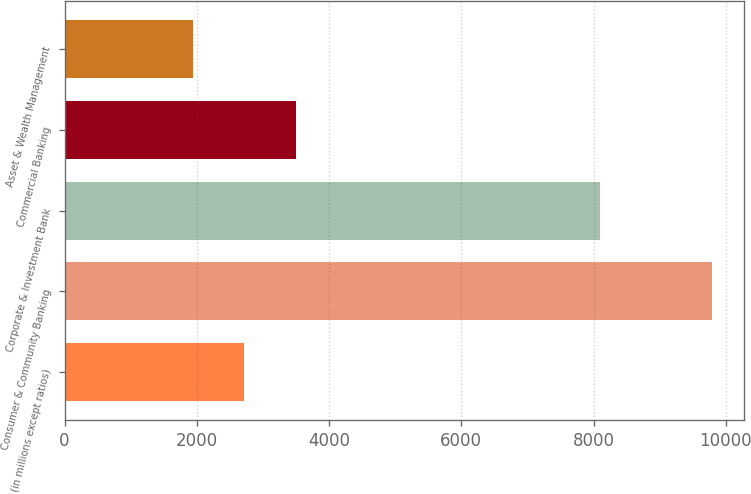<chart> <loc_0><loc_0><loc_500><loc_500><bar_chart><fcel>(in millions except ratios)<fcel>Consumer & Community Banking<fcel>Corporate & Investment Bank<fcel>Commercial Banking<fcel>Asset & Wealth Management<nl><fcel>2720.4<fcel>9789<fcel>8090<fcel>3505.8<fcel>1935<nl></chart> 